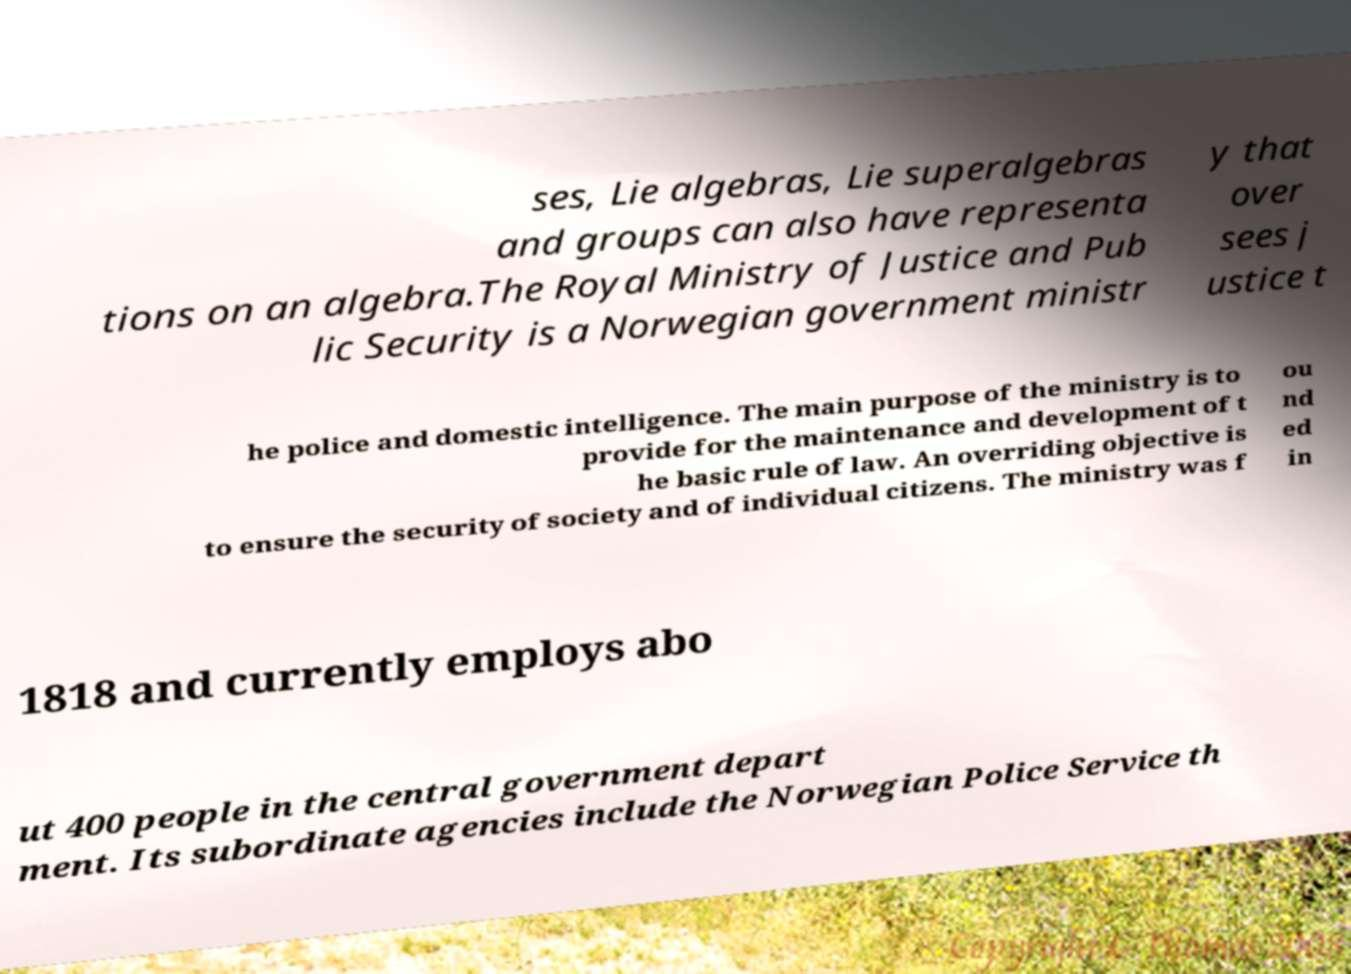Can you accurately transcribe the text from the provided image for me? ses, Lie algebras, Lie superalgebras and groups can also have representa tions on an algebra.The Royal Ministry of Justice and Pub lic Security is a Norwegian government ministr y that over sees j ustice t he police and domestic intelligence. The main purpose of the ministry is to provide for the maintenance and development of t he basic rule of law. An overriding objective is to ensure the security of society and of individual citizens. The ministry was f ou nd ed in 1818 and currently employs abo ut 400 people in the central government depart ment. Its subordinate agencies include the Norwegian Police Service th 